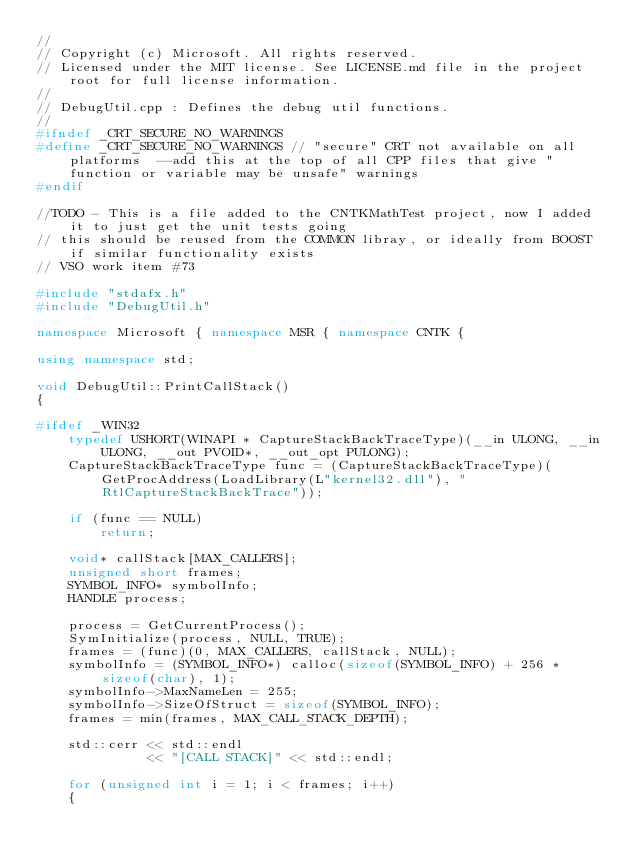<code> <loc_0><loc_0><loc_500><loc_500><_C++_>//
// Copyright (c) Microsoft. All rights reserved.
// Licensed under the MIT license. See LICENSE.md file in the project root for full license information.
//
// DebugUtil.cpp : Defines the debug util functions.
//
#ifndef _CRT_SECURE_NO_WARNINGS
#define _CRT_SECURE_NO_WARNINGS // "secure" CRT not available on all platforms  --add this at the top of all CPP files that give "function or variable may be unsafe" warnings
#endif

//TODO - This is a file added to the CNTKMathTest project, now I added it to just get the unit tests going
// this should be reused from the COMMON libray, or ideally from BOOST if similar functionality exists
// VSO work item #73

#include "stdafx.h"
#include "DebugUtil.h"

namespace Microsoft { namespace MSR { namespace CNTK {

using namespace std;

void DebugUtil::PrintCallStack()
{

#ifdef _WIN32
    typedef USHORT(WINAPI * CaptureStackBackTraceType)(__in ULONG, __in ULONG, __out PVOID*, __out_opt PULONG);
    CaptureStackBackTraceType func = (CaptureStackBackTraceType)(GetProcAddress(LoadLibrary(L"kernel32.dll"), "RtlCaptureStackBackTrace"));

    if (func == NULL)
        return;

    void* callStack[MAX_CALLERS];
    unsigned short frames;
    SYMBOL_INFO* symbolInfo;
    HANDLE process;

    process = GetCurrentProcess();
    SymInitialize(process, NULL, TRUE);
    frames = (func)(0, MAX_CALLERS, callStack, NULL);
    symbolInfo = (SYMBOL_INFO*) calloc(sizeof(SYMBOL_INFO) + 256 * sizeof(char), 1);
    symbolInfo->MaxNameLen = 255;
    symbolInfo->SizeOfStruct = sizeof(SYMBOL_INFO);
    frames = min(frames, MAX_CALL_STACK_DEPTH);

    std::cerr << std::endl
              << "[CALL STACK]" << std::endl;

    for (unsigned int i = 1; i < frames; i++)
    {</code> 